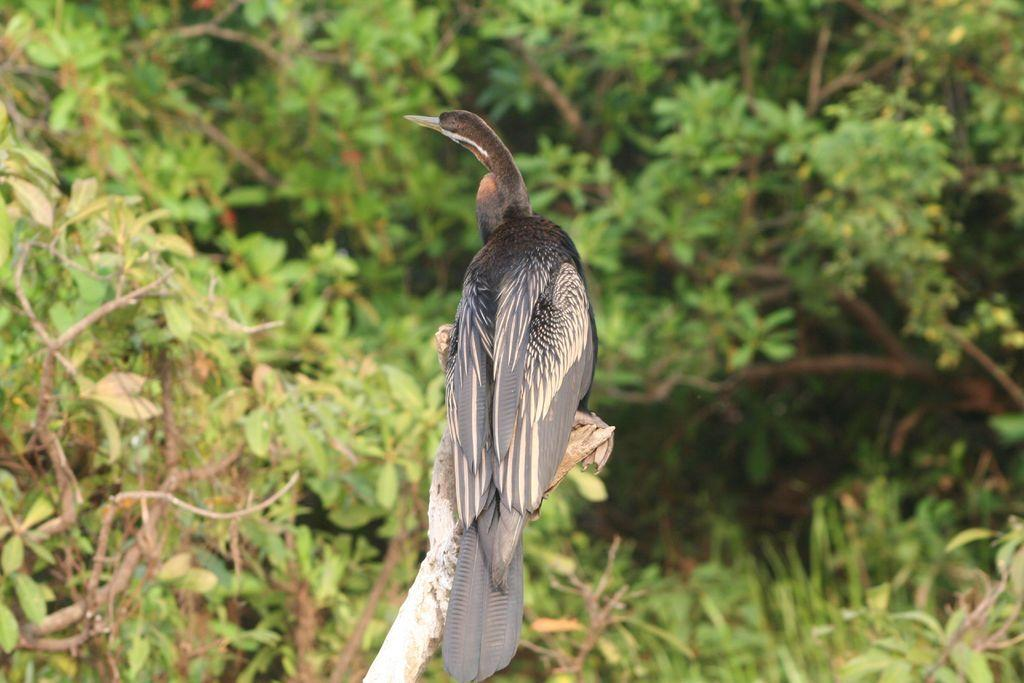Where was the image taken? The image was taken outdoors. What can be seen in the background of the image? There are many trees in the background of the image. What is the bird doing in the image? The bird is on the bark in the middle of the image. What type of powder is being used by the bird in the image? There is no powder present in the image; the bird is simply perched on the bark. 